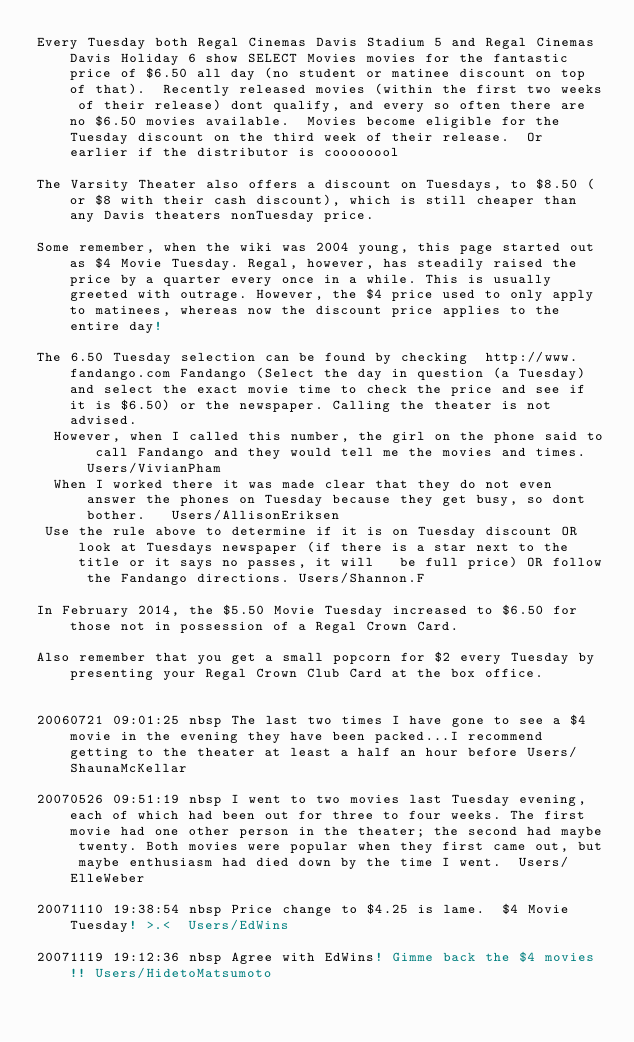Convert code to text. <code><loc_0><loc_0><loc_500><loc_500><_FORTRAN_>Every Tuesday both Regal Cinemas Davis Stadium 5 and Regal Cinemas Davis Holiday 6 show SELECT Movies movies for the fantastic price of $6.50 all day (no student or matinee discount on top of that).  Recently released movies (within the first two weeks of their release) dont qualify, and every so often there are no $6.50 movies available.  Movies become eligible for the Tuesday discount on the third week of their release.  Or earlier if the distributor is coooooool

The Varsity Theater also offers a discount on Tuesdays, to $8.50 (or $8 with their cash discount), which is still cheaper than any Davis theaters nonTuesday price.

Some remember, when the wiki was 2004 young, this page started out as $4 Movie Tuesday. Regal, however, has steadily raised the price by a quarter every once in a while. This is usually greeted with outrage. However, the $4 price used to only apply to matinees, whereas now the discount price applies to the entire day!

The 6.50 Tuesday selection can be found by checking  http://www.fandango.com Fandango (Select the day in question (a Tuesday) and select the exact movie time to check the price and see if it is $6.50) or the newspaper. Calling the theater is not advised.
  However, when I called this number, the girl on the phone said to call Fandango and they would tell me the movies and times. Users/VivianPham
  When I worked there it was made clear that they do not even answer the phones on Tuesday because they get busy, so dont bother.   Users/AllisonEriksen
 Use the rule above to determine if it is on Tuesday discount OR look at Tuesdays newspaper (if there is a star next to the title or it says no passes, it will   be full price) OR follow the Fandango directions. Users/Shannon.F

In February 2014, the $5.50 Movie Tuesday increased to $6.50 for those not in possession of a Regal Crown Card.

Also remember that you get a small popcorn for $2 every Tuesday by presenting your Regal Crown Club Card at the box office.


20060721 09:01:25 nbsp The last two times I have gone to see a $4 movie in the evening they have been packed...I recommend getting to the theater at least a half an hour before Users/ShaunaMcKellar

20070526 09:51:19 nbsp I went to two movies last Tuesday evening, each of which had been out for three to four weeks. The first movie had one other person in the theater; the second had maybe twenty. Both movies were popular when they first came out, but maybe enthusiasm had died down by the time I went.  Users/ElleWeber

20071110 19:38:54 nbsp Price change to $4.25 is lame.  $4 Movie Tuesday! >.<  Users/EdWins

20071119 19:12:36 nbsp Agree with EdWins! Gimme back the $4 movies!! Users/HidetoMatsumoto
</code> 